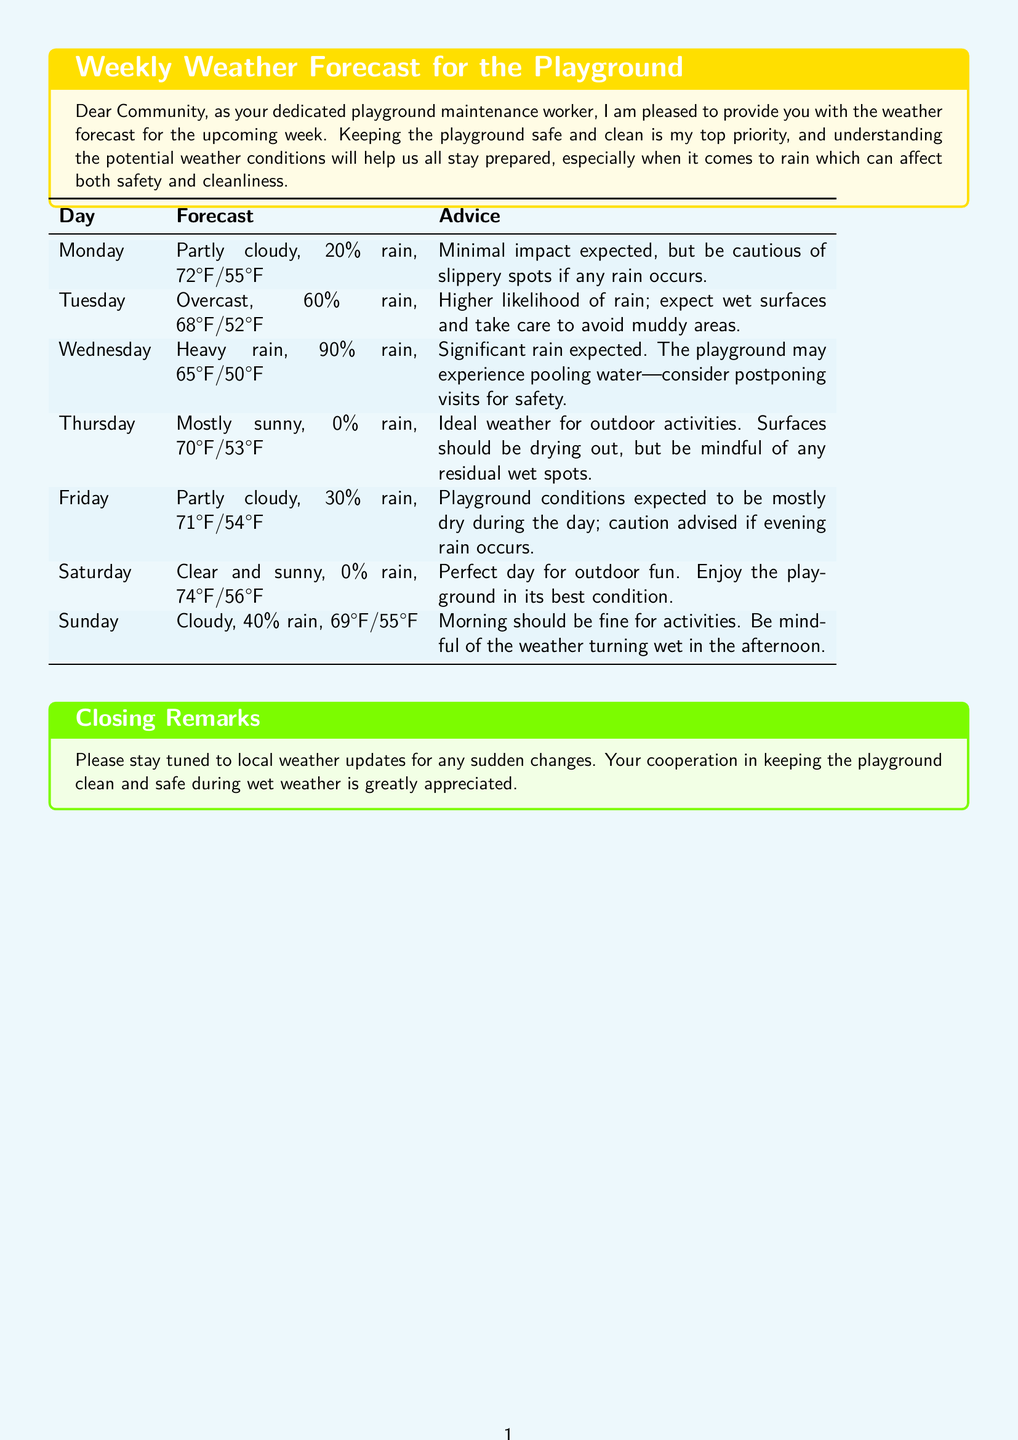What is the expected temperature on Wednesday? The expected temperature on Wednesday is 65°F/50°F as mentioned in the forecast table.
Answer: 65°F/50°F What is the rain probability on Tuesday? The rain probability for Tuesday is stated as 60% in the table.
Answer: 60% What should you avoid on Tuesday according to the advice? The advice for Tuesday suggests avoiding muddy areas due to the expected wet surfaces.
Answer: Muddy areas What is the condition of the playground on Thursday? Thursday is forecasted to be mostly sunny with a 0% chance of rain, indicating ideal conditions for the playground.
Answer: Ideal conditions Which day has the highest chance of rain? The day with the highest chance of rain is Wednesday, with a 90% forecast of rain.
Answer: Wednesday What is the weather like on Saturday? Saturday is predicted to be clear and sunny with a 0% chance of rain, perfect for outdoor activities.
Answer: Clear and sunny When should caution be taken due to potential rain? Caution should be taken on Friday if evening rain occurs, as indicated in the advice.
Answer: Friday evening What is the advice for Sunday regarding activities? The advice for Sunday indicates that the morning should be fine for activities, but to be mindful of possible rain in the afternoon.
Answer: Mindful of possible rain in the afternoon What color is the background of the weather forecast box? The background of the weather forecast box is a light shade of yellow, as noted in the document's description.
Answer: Light yellow 